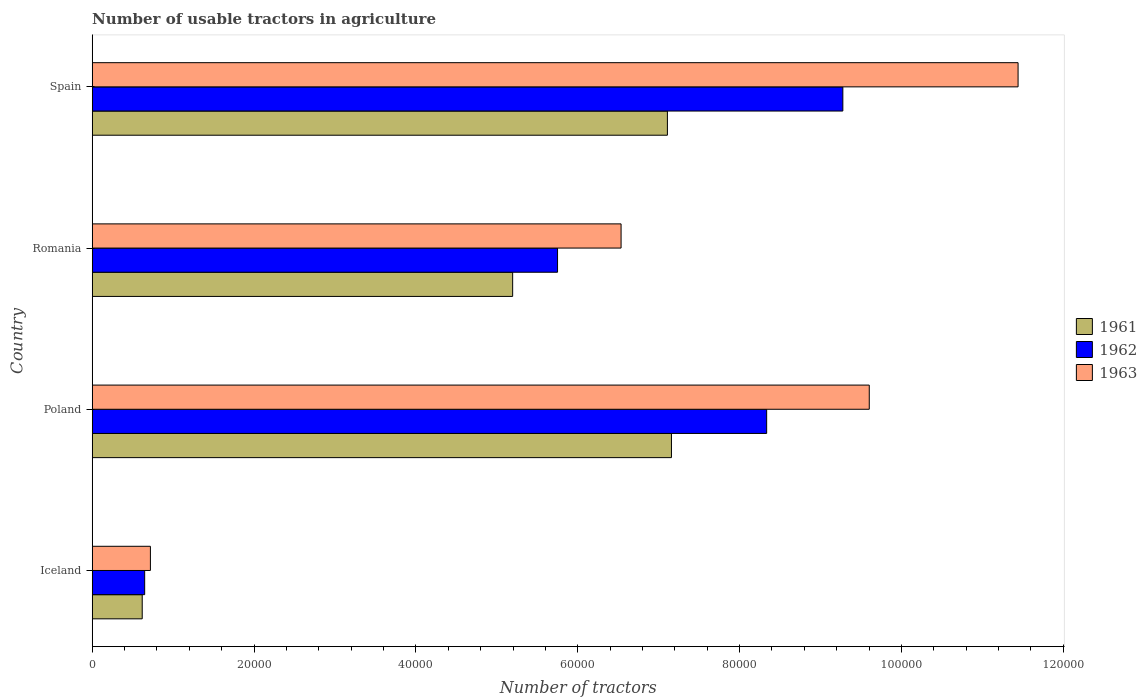How many groups of bars are there?
Offer a very short reply. 4. Are the number of bars on each tick of the Y-axis equal?
Offer a terse response. Yes. How many bars are there on the 1st tick from the top?
Offer a terse response. 3. How many bars are there on the 2nd tick from the bottom?
Offer a very short reply. 3. What is the label of the 2nd group of bars from the top?
Offer a very short reply. Romania. In how many cases, is the number of bars for a given country not equal to the number of legend labels?
Offer a terse response. 0. What is the number of usable tractors in agriculture in 1961 in Poland?
Offer a very short reply. 7.16e+04. Across all countries, what is the maximum number of usable tractors in agriculture in 1961?
Your response must be concise. 7.16e+04. Across all countries, what is the minimum number of usable tractors in agriculture in 1963?
Provide a succinct answer. 7187. In which country was the number of usable tractors in agriculture in 1962 maximum?
Ensure brevity in your answer.  Spain. What is the total number of usable tractors in agriculture in 1961 in the graph?
Your response must be concise. 2.01e+05. What is the difference between the number of usable tractors in agriculture in 1962 in Iceland and that in Romania?
Make the answer very short. -5.10e+04. What is the difference between the number of usable tractors in agriculture in 1961 in Spain and the number of usable tractors in agriculture in 1962 in Iceland?
Offer a very short reply. 6.46e+04. What is the average number of usable tractors in agriculture in 1963 per country?
Give a very brief answer. 7.07e+04. What is the difference between the number of usable tractors in agriculture in 1962 and number of usable tractors in agriculture in 1961 in Spain?
Keep it short and to the point. 2.17e+04. In how many countries, is the number of usable tractors in agriculture in 1962 greater than 40000 ?
Provide a short and direct response. 3. What is the ratio of the number of usable tractors in agriculture in 1961 in Iceland to that in Romania?
Provide a succinct answer. 0.12. Is the number of usable tractors in agriculture in 1963 in Iceland less than that in Spain?
Your answer should be very brief. Yes. What is the difference between the highest and the second highest number of usable tractors in agriculture in 1963?
Provide a succinct answer. 1.84e+04. What is the difference between the highest and the lowest number of usable tractors in agriculture in 1962?
Your answer should be compact. 8.63e+04. Is the sum of the number of usable tractors in agriculture in 1963 in Poland and Romania greater than the maximum number of usable tractors in agriculture in 1961 across all countries?
Give a very brief answer. Yes. What does the 3rd bar from the top in Iceland represents?
Ensure brevity in your answer.  1961. Is it the case that in every country, the sum of the number of usable tractors in agriculture in 1961 and number of usable tractors in agriculture in 1962 is greater than the number of usable tractors in agriculture in 1963?
Provide a short and direct response. Yes. Are all the bars in the graph horizontal?
Your response must be concise. Yes. What is the difference between two consecutive major ticks on the X-axis?
Provide a short and direct response. 2.00e+04. Are the values on the major ticks of X-axis written in scientific E-notation?
Offer a very short reply. No. Does the graph contain any zero values?
Provide a short and direct response. No. Where does the legend appear in the graph?
Your answer should be very brief. Center right. How are the legend labels stacked?
Your response must be concise. Vertical. What is the title of the graph?
Ensure brevity in your answer.  Number of usable tractors in agriculture. What is the label or title of the X-axis?
Provide a short and direct response. Number of tractors. What is the label or title of the Y-axis?
Your answer should be very brief. Country. What is the Number of tractors in 1961 in Iceland?
Your answer should be compact. 6177. What is the Number of tractors of 1962 in Iceland?
Offer a very short reply. 6479. What is the Number of tractors of 1963 in Iceland?
Provide a succinct answer. 7187. What is the Number of tractors in 1961 in Poland?
Provide a succinct answer. 7.16e+04. What is the Number of tractors of 1962 in Poland?
Your response must be concise. 8.33e+04. What is the Number of tractors of 1963 in Poland?
Make the answer very short. 9.60e+04. What is the Number of tractors in 1961 in Romania?
Provide a short and direct response. 5.20e+04. What is the Number of tractors of 1962 in Romania?
Your response must be concise. 5.75e+04. What is the Number of tractors of 1963 in Romania?
Your response must be concise. 6.54e+04. What is the Number of tractors in 1961 in Spain?
Your response must be concise. 7.11e+04. What is the Number of tractors in 1962 in Spain?
Offer a terse response. 9.28e+04. What is the Number of tractors of 1963 in Spain?
Provide a succinct answer. 1.14e+05. Across all countries, what is the maximum Number of tractors in 1961?
Ensure brevity in your answer.  7.16e+04. Across all countries, what is the maximum Number of tractors of 1962?
Provide a succinct answer. 9.28e+04. Across all countries, what is the maximum Number of tractors in 1963?
Your response must be concise. 1.14e+05. Across all countries, what is the minimum Number of tractors in 1961?
Your answer should be compact. 6177. Across all countries, what is the minimum Number of tractors of 1962?
Give a very brief answer. 6479. Across all countries, what is the minimum Number of tractors of 1963?
Keep it short and to the point. 7187. What is the total Number of tractors of 1961 in the graph?
Provide a short and direct response. 2.01e+05. What is the total Number of tractors of 1962 in the graph?
Make the answer very short. 2.40e+05. What is the total Number of tractors in 1963 in the graph?
Keep it short and to the point. 2.83e+05. What is the difference between the Number of tractors of 1961 in Iceland and that in Poland?
Make the answer very short. -6.54e+04. What is the difference between the Number of tractors of 1962 in Iceland and that in Poland?
Give a very brief answer. -7.69e+04. What is the difference between the Number of tractors of 1963 in Iceland and that in Poland?
Your answer should be very brief. -8.88e+04. What is the difference between the Number of tractors of 1961 in Iceland and that in Romania?
Keep it short and to the point. -4.58e+04. What is the difference between the Number of tractors of 1962 in Iceland and that in Romania?
Your answer should be very brief. -5.10e+04. What is the difference between the Number of tractors of 1963 in Iceland and that in Romania?
Offer a terse response. -5.82e+04. What is the difference between the Number of tractors of 1961 in Iceland and that in Spain?
Make the answer very short. -6.49e+04. What is the difference between the Number of tractors of 1962 in Iceland and that in Spain?
Give a very brief answer. -8.63e+04. What is the difference between the Number of tractors in 1963 in Iceland and that in Spain?
Your answer should be compact. -1.07e+05. What is the difference between the Number of tractors of 1961 in Poland and that in Romania?
Give a very brief answer. 1.96e+04. What is the difference between the Number of tractors of 1962 in Poland and that in Romania?
Provide a succinct answer. 2.58e+04. What is the difference between the Number of tractors in 1963 in Poland and that in Romania?
Provide a short and direct response. 3.07e+04. What is the difference between the Number of tractors of 1961 in Poland and that in Spain?
Your response must be concise. 500. What is the difference between the Number of tractors of 1962 in Poland and that in Spain?
Provide a short and direct response. -9414. What is the difference between the Number of tractors of 1963 in Poland and that in Spain?
Give a very brief answer. -1.84e+04. What is the difference between the Number of tractors in 1961 in Romania and that in Spain?
Offer a very short reply. -1.91e+04. What is the difference between the Number of tractors of 1962 in Romania and that in Spain?
Give a very brief answer. -3.53e+04. What is the difference between the Number of tractors in 1963 in Romania and that in Spain?
Make the answer very short. -4.91e+04. What is the difference between the Number of tractors in 1961 in Iceland and the Number of tractors in 1962 in Poland?
Offer a terse response. -7.72e+04. What is the difference between the Number of tractors of 1961 in Iceland and the Number of tractors of 1963 in Poland?
Your response must be concise. -8.98e+04. What is the difference between the Number of tractors of 1962 in Iceland and the Number of tractors of 1963 in Poland?
Ensure brevity in your answer.  -8.95e+04. What is the difference between the Number of tractors in 1961 in Iceland and the Number of tractors in 1962 in Romania?
Your response must be concise. -5.13e+04. What is the difference between the Number of tractors of 1961 in Iceland and the Number of tractors of 1963 in Romania?
Offer a terse response. -5.92e+04. What is the difference between the Number of tractors of 1962 in Iceland and the Number of tractors of 1963 in Romania?
Keep it short and to the point. -5.89e+04. What is the difference between the Number of tractors of 1961 in Iceland and the Number of tractors of 1962 in Spain?
Your answer should be compact. -8.66e+04. What is the difference between the Number of tractors in 1961 in Iceland and the Number of tractors in 1963 in Spain?
Your answer should be very brief. -1.08e+05. What is the difference between the Number of tractors in 1962 in Iceland and the Number of tractors in 1963 in Spain?
Give a very brief answer. -1.08e+05. What is the difference between the Number of tractors in 1961 in Poland and the Number of tractors in 1962 in Romania?
Offer a very short reply. 1.41e+04. What is the difference between the Number of tractors in 1961 in Poland and the Number of tractors in 1963 in Romania?
Your answer should be very brief. 6226. What is the difference between the Number of tractors in 1962 in Poland and the Number of tractors in 1963 in Romania?
Your response must be concise. 1.80e+04. What is the difference between the Number of tractors of 1961 in Poland and the Number of tractors of 1962 in Spain?
Make the answer very short. -2.12e+04. What is the difference between the Number of tractors of 1961 in Poland and the Number of tractors of 1963 in Spain?
Keep it short and to the point. -4.28e+04. What is the difference between the Number of tractors in 1962 in Poland and the Number of tractors in 1963 in Spain?
Provide a succinct answer. -3.11e+04. What is the difference between the Number of tractors of 1961 in Romania and the Number of tractors of 1962 in Spain?
Give a very brief answer. -4.08e+04. What is the difference between the Number of tractors of 1961 in Romania and the Number of tractors of 1963 in Spain?
Make the answer very short. -6.25e+04. What is the difference between the Number of tractors in 1962 in Romania and the Number of tractors in 1963 in Spain?
Provide a short and direct response. -5.69e+04. What is the average Number of tractors of 1961 per country?
Your answer should be compact. 5.02e+04. What is the average Number of tractors in 1962 per country?
Make the answer very short. 6.00e+04. What is the average Number of tractors in 1963 per country?
Make the answer very short. 7.07e+04. What is the difference between the Number of tractors in 1961 and Number of tractors in 1962 in Iceland?
Provide a succinct answer. -302. What is the difference between the Number of tractors in 1961 and Number of tractors in 1963 in Iceland?
Your answer should be compact. -1010. What is the difference between the Number of tractors of 1962 and Number of tractors of 1963 in Iceland?
Make the answer very short. -708. What is the difference between the Number of tractors in 1961 and Number of tractors in 1962 in Poland?
Your answer should be very brief. -1.18e+04. What is the difference between the Number of tractors in 1961 and Number of tractors in 1963 in Poland?
Provide a short and direct response. -2.44e+04. What is the difference between the Number of tractors of 1962 and Number of tractors of 1963 in Poland?
Ensure brevity in your answer.  -1.27e+04. What is the difference between the Number of tractors in 1961 and Number of tractors in 1962 in Romania?
Provide a short and direct response. -5548. What is the difference between the Number of tractors of 1961 and Number of tractors of 1963 in Romania?
Keep it short and to the point. -1.34e+04. What is the difference between the Number of tractors of 1962 and Number of tractors of 1963 in Romania?
Keep it short and to the point. -7851. What is the difference between the Number of tractors of 1961 and Number of tractors of 1962 in Spain?
Your answer should be very brief. -2.17e+04. What is the difference between the Number of tractors in 1961 and Number of tractors in 1963 in Spain?
Keep it short and to the point. -4.33e+04. What is the difference between the Number of tractors of 1962 and Number of tractors of 1963 in Spain?
Give a very brief answer. -2.17e+04. What is the ratio of the Number of tractors of 1961 in Iceland to that in Poland?
Offer a terse response. 0.09. What is the ratio of the Number of tractors in 1962 in Iceland to that in Poland?
Offer a terse response. 0.08. What is the ratio of the Number of tractors of 1963 in Iceland to that in Poland?
Give a very brief answer. 0.07. What is the ratio of the Number of tractors in 1961 in Iceland to that in Romania?
Ensure brevity in your answer.  0.12. What is the ratio of the Number of tractors of 1962 in Iceland to that in Romania?
Your answer should be compact. 0.11. What is the ratio of the Number of tractors in 1963 in Iceland to that in Romania?
Your answer should be very brief. 0.11. What is the ratio of the Number of tractors of 1961 in Iceland to that in Spain?
Provide a succinct answer. 0.09. What is the ratio of the Number of tractors of 1962 in Iceland to that in Spain?
Your answer should be compact. 0.07. What is the ratio of the Number of tractors of 1963 in Iceland to that in Spain?
Offer a terse response. 0.06. What is the ratio of the Number of tractors in 1961 in Poland to that in Romania?
Your answer should be very brief. 1.38. What is the ratio of the Number of tractors of 1962 in Poland to that in Romania?
Give a very brief answer. 1.45. What is the ratio of the Number of tractors in 1963 in Poland to that in Romania?
Give a very brief answer. 1.47. What is the ratio of the Number of tractors in 1961 in Poland to that in Spain?
Ensure brevity in your answer.  1.01. What is the ratio of the Number of tractors in 1962 in Poland to that in Spain?
Your answer should be compact. 0.9. What is the ratio of the Number of tractors of 1963 in Poland to that in Spain?
Keep it short and to the point. 0.84. What is the ratio of the Number of tractors of 1961 in Romania to that in Spain?
Keep it short and to the point. 0.73. What is the ratio of the Number of tractors in 1962 in Romania to that in Spain?
Your answer should be compact. 0.62. What is the ratio of the Number of tractors of 1963 in Romania to that in Spain?
Your answer should be compact. 0.57. What is the difference between the highest and the second highest Number of tractors in 1962?
Your answer should be compact. 9414. What is the difference between the highest and the second highest Number of tractors of 1963?
Your answer should be compact. 1.84e+04. What is the difference between the highest and the lowest Number of tractors in 1961?
Give a very brief answer. 6.54e+04. What is the difference between the highest and the lowest Number of tractors of 1962?
Ensure brevity in your answer.  8.63e+04. What is the difference between the highest and the lowest Number of tractors of 1963?
Give a very brief answer. 1.07e+05. 